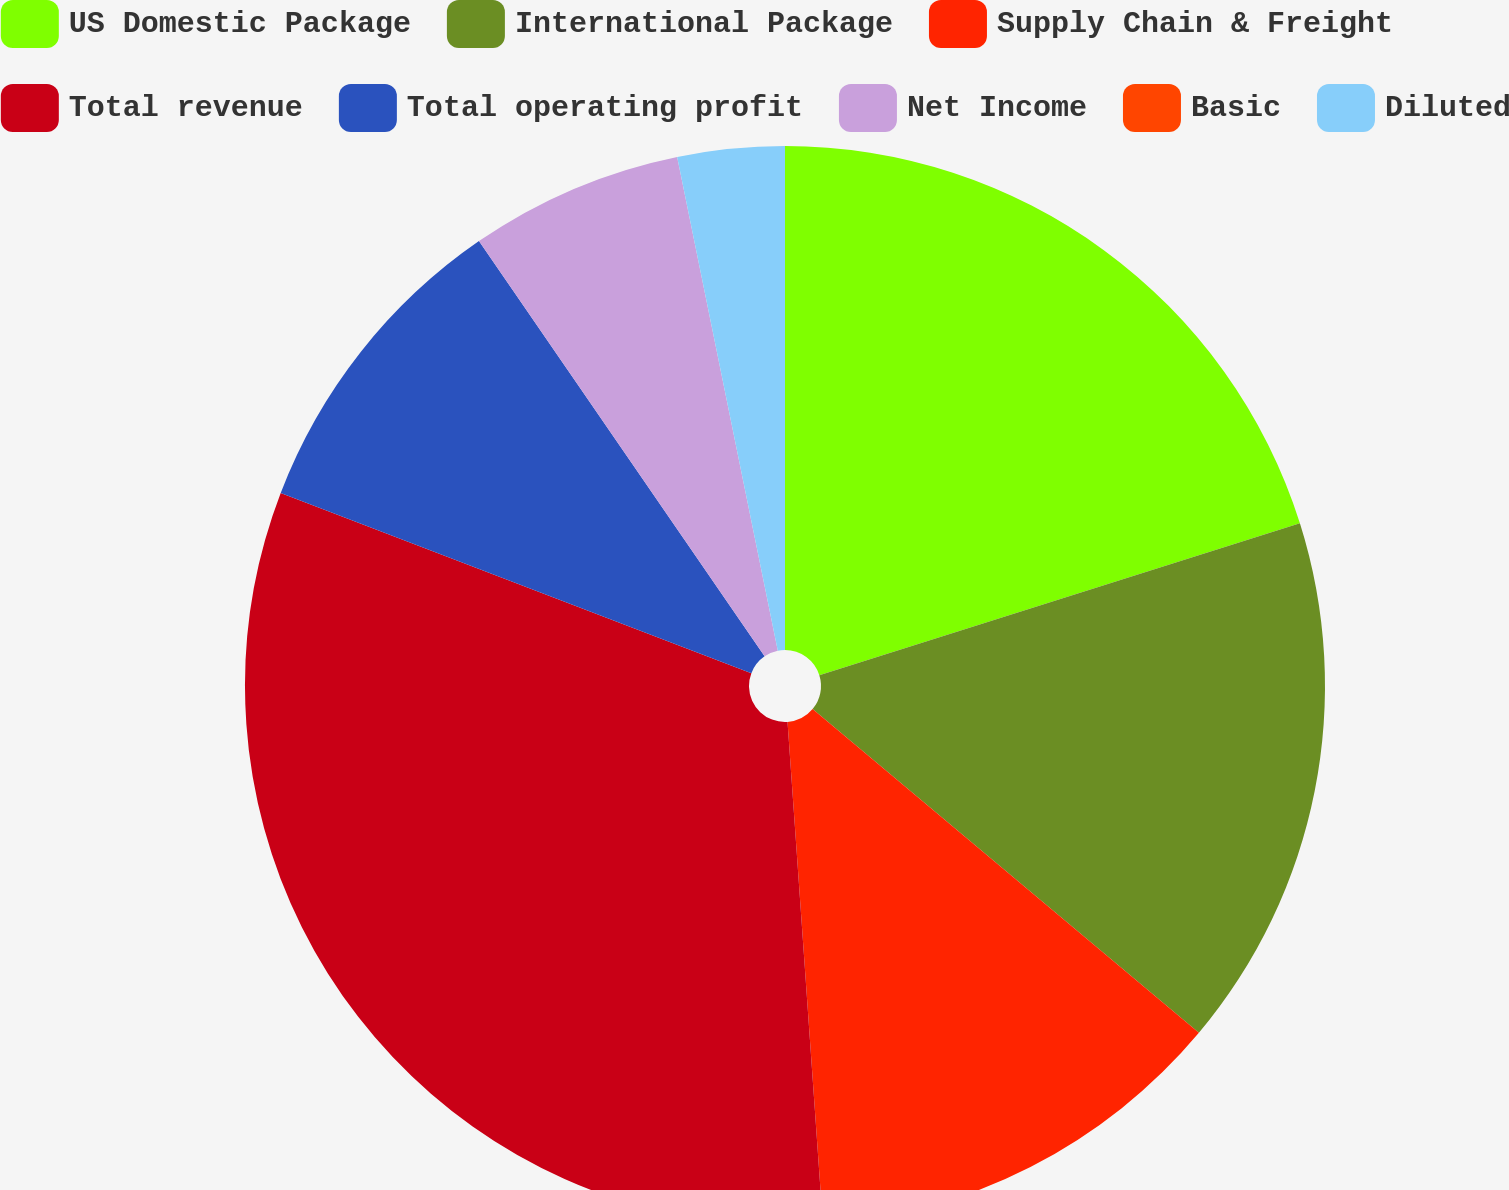Convert chart. <chart><loc_0><loc_0><loc_500><loc_500><pie_chart><fcel>US Domestic Package<fcel>International Package<fcel>Supply Chain & Freight<fcel>Total revenue<fcel>Total operating profit<fcel>Net Income<fcel>Basic<fcel>Diluted<nl><fcel>20.13%<fcel>15.97%<fcel>12.78%<fcel>31.94%<fcel>9.59%<fcel>6.39%<fcel>0.0%<fcel>3.2%<nl></chart> 